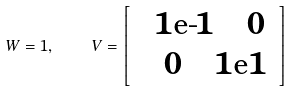Convert formula to latex. <formula><loc_0><loc_0><loc_500><loc_500>W = 1 , \quad \, V = \left [ { \begin{array} { c c } & 1 \text {e-} 1 \quad 0 \, \\ & \, 0 \quad 1 \text {e} 1 \end{array} } \right ]</formula> 